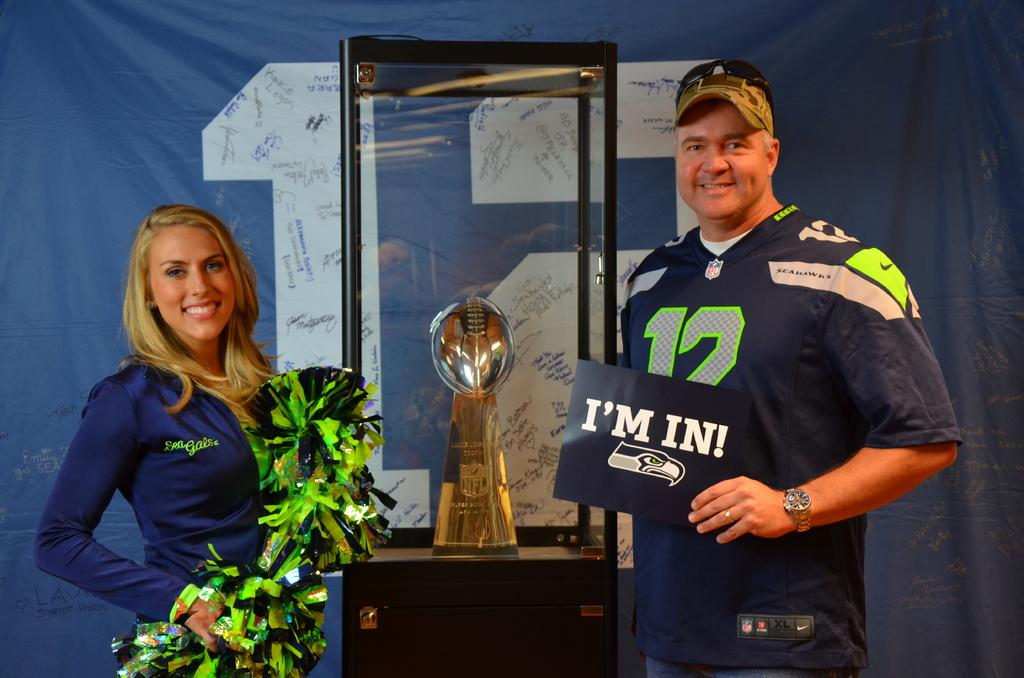Provide a one-sentence caption for the provided image. A man poses with an NFL trophy and one of the Sea Gals. 